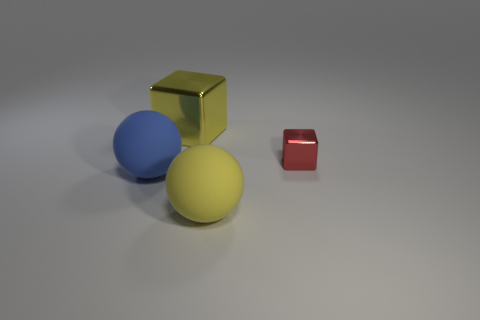There is a big metal block; is its color the same as the rubber sphere that is right of the big blue thing?
Your answer should be very brief. Yes. What is the shape of the matte object that is the same color as the large metal object?
Make the answer very short. Sphere. What number of other objects are the same size as the blue thing?
Your answer should be compact. 2. How many large blue spheres have the same material as the small red block?
Your answer should be compact. 0. What is the color of the large thing that is made of the same material as the small red cube?
Ensure brevity in your answer.  Yellow. Is the blue object the same shape as the big yellow matte object?
Provide a short and direct response. Yes. Is there a matte sphere that is on the right side of the cube that is to the left of the metallic block that is on the right side of the large shiny thing?
Give a very brief answer. Yes. How many rubber objects have the same color as the big metallic object?
Offer a very short reply. 1. What shape is the matte thing that is the same size as the blue matte sphere?
Provide a short and direct response. Sphere. Are there any matte spheres on the right side of the yellow block?
Offer a very short reply. Yes. 